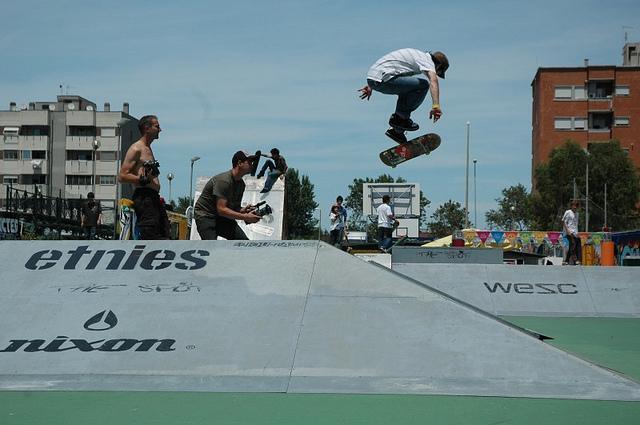How many buildings are in the picture?
Give a very brief answer. 3. How many people are in the picture?
Give a very brief answer. 3. 